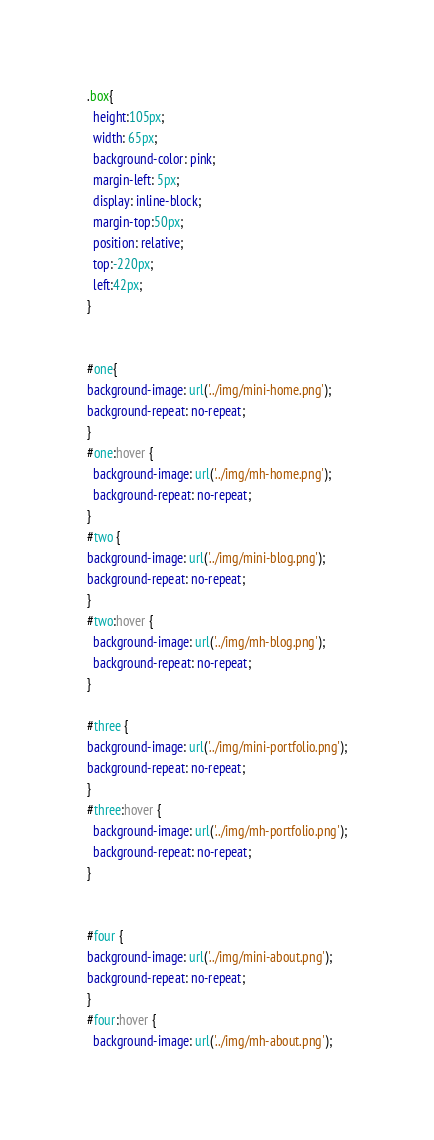<code> <loc_0><loc_0><loc_500><loc_500><_CSS_>.box{
  height:105px;
  width: 65px;
  background-color: pink;
  margin-left: 5px;
  display: inline-block;
  margin-top:50px;
  position: relative;
  top:-220px;
  left:42px;
}


#one{
background-image: url('../img/mini-home.png');
background-repeat: no-repeat;
}
#one:hover {
  background-image: url('../img/mh-home.png');
  background-repeat: no-repeat;
}
#two {
background-image: url('../img/mini-blog.png');
background-repeat: no-repeat;
}
#two:hover {
  background-image: url('../img/mh-blog.png');
  background-repeat: no-repeat;
}

#three {
background-image: url('../img/mini-portfolio.png');
background-repeat: no-repeat;
}
#three:hover {
  background-image: url('../img/mh-portfolio.png');
  background-repeat: no-repeat;
}


#four {
background-image: url('../img/mini-about.png');
background-repeat: no-repeat;
}
#four:hover {
  background-image: url('../img/mh-about.png');</code> 